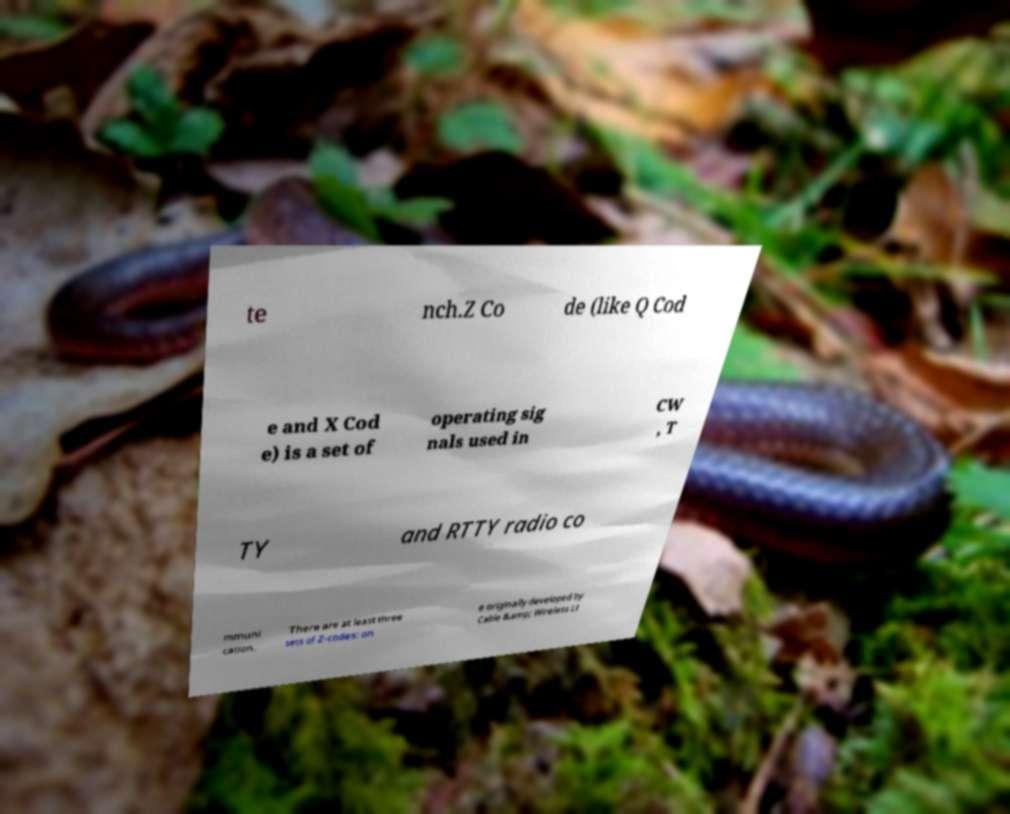Could you assist in decoding the text presented in this image and type it out clearly? te nch.Z Co de (like Q Cod e and X Cod e) is a set of operating sig nals used in CW , T TY and RTTY radio co mmuni cation. There are at least three sets of Z-codes: on e originally developed by Cable &amp; Wireless Lt 